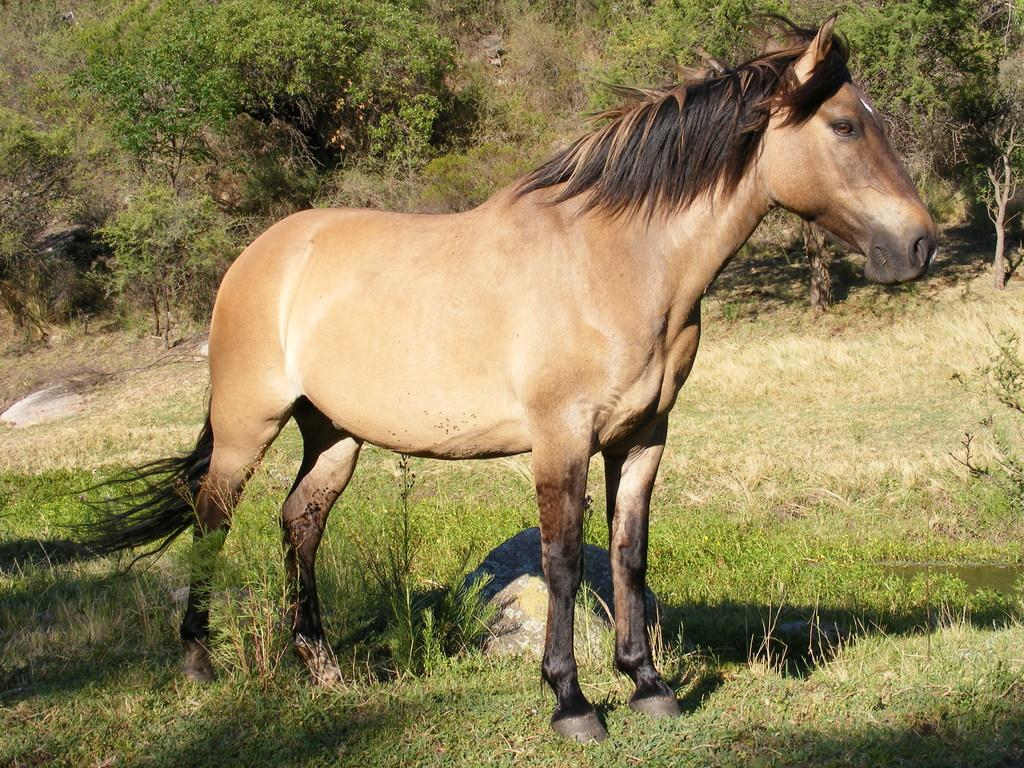What is the main subject in the foreground of the image? There is a horse in the foreground of the image. What is the horse standing on? The horse is standing on the grass. Can you describe the object behind the horse? There is a stone behind the horse. What can be seen in the background of the image? There are trees in the background of the image. What type of card is being played by the horse in the image? There is no card or card game present in the image; it features a horse standing on grass with a stone behind it and trees in the background. 